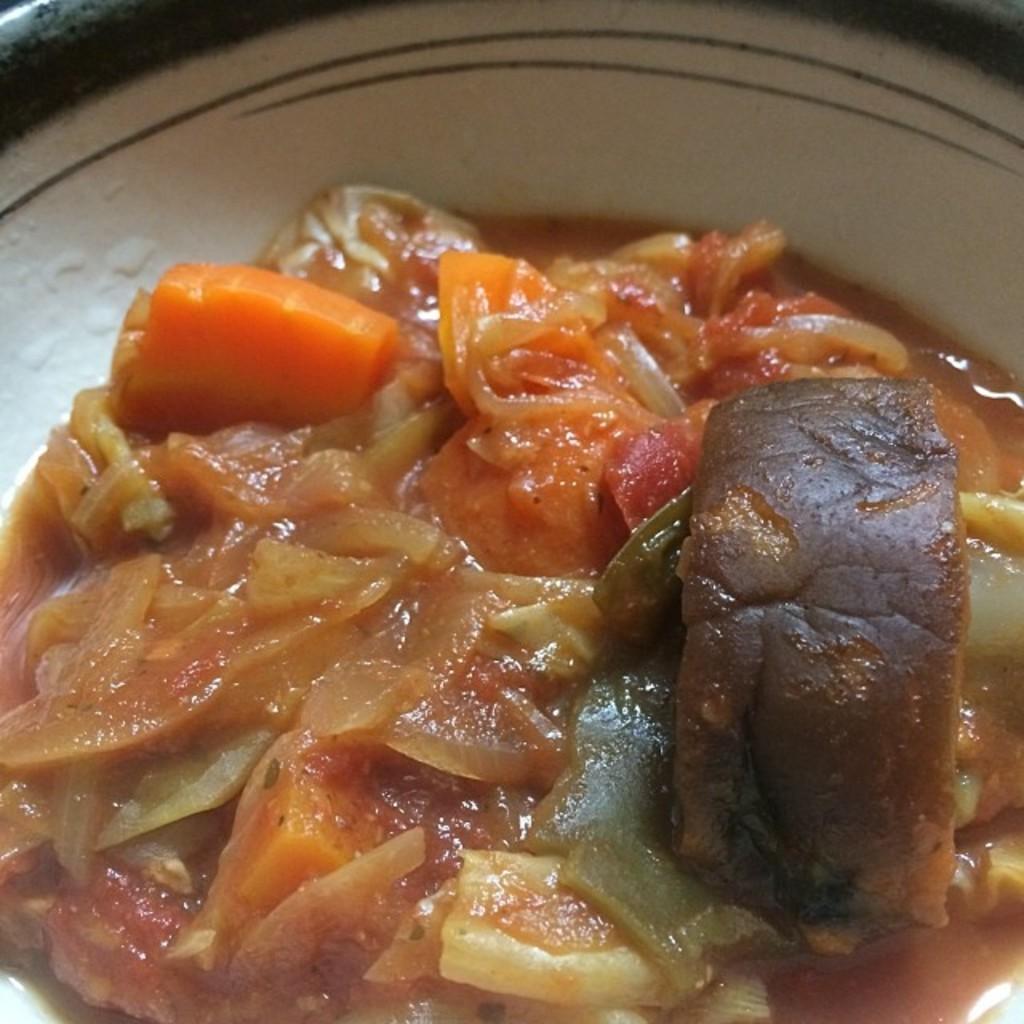Could you give a brief overview of what you see in this image? This is a zoomed in picture. In the center we can see a white color object containing some food item. 